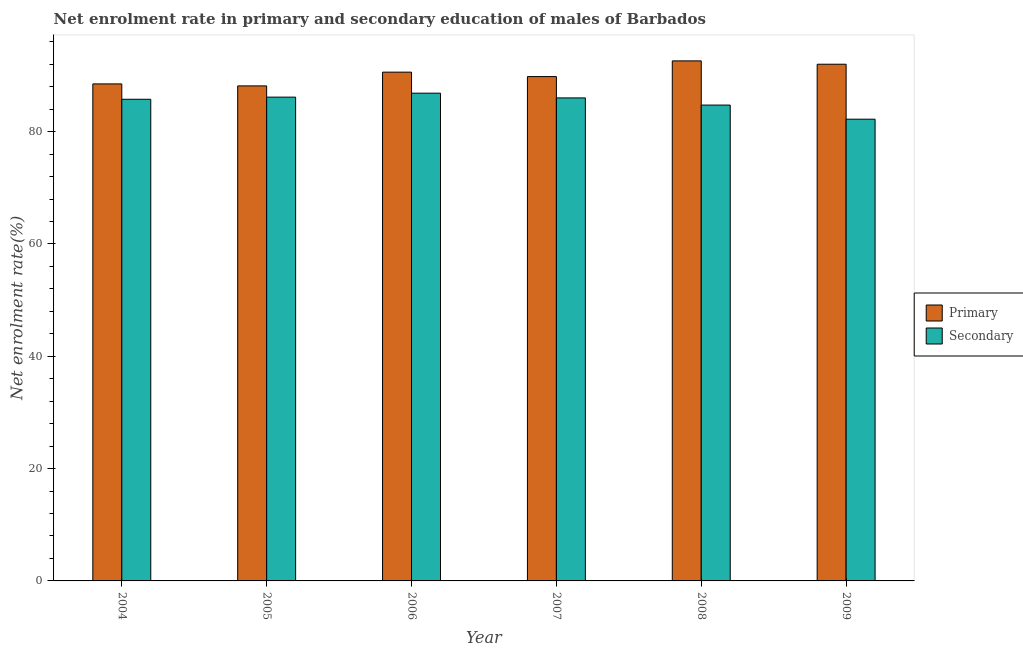How many groups of bars are there?
Give a very brief answer. 6. How many bars are there on the 3rd tick from the left?
Provide a succinct answer. 2. In how many cases, is the number of bars for a given year not equal to the number of legend labels?
Provide a succinct answer. 0. What is the enrollment rate in primary education in 2005?
Offer a terse response. 88.15. Across all years, what is the maximum enrollment rate in primary education?
Your response must be concise. 92.61. Across all years, what is the minimum enrollment rate in secondary education?
Offer a terse response. 82.22. In which year was the enrollment rate in primary education maximum?
Offer a very short reply. 2008. In which year was the enrollment rate in primary education minimum?
Provide a short and direct response. 2005. What is the total enrollment rate in secondary education in the graph?
Your answer should be compact. 511.73. What is the difference between the enrollment rate in secondary education in 2004 and that in 2007?
Keep it short and to the point. -0.24. What is the difference between the enrollment rate in primary education in 2008 and the enrollment rate in secondary education in 2007?
Your response must be concise. 2.8. What is the average enrollment rate in secondary education per year?
Your answer should be compact. 85.29. In how many years, is the enrollment rate in secondary education greater than 8 %?
Your response must be concise. 6. What is the ratio of the enrollment rate in secondary education in 2004 to that in 2005?
Provide a short and direct response. 1. Is the difference between the enrollment rate in primary education in 2006 and 2008 greater than the difference between the enrollment rate in secondary education in 2006 and 2008?
Your response must be concise. No. What is the difference between the highest and the second highest enrollment rate in primary education?
Provide a succinct answer. 0.6. What is the difference between the highest and the lowest enrollment rate in primary education?
Your answer should be very brief. 4.46. In how many years, is the enrollment rate in primary education greater than the average enrollment rate in primary education taken over all years?
Your response must be concise. 3. What does the 2nd bar from the left in 2007 represents?
Your answer should be compact. Secondary. What does the 2nd bar from the right in 2006 represents?
Provide a succinct answer. Primary. How many bars are there?
Provide a succinct answer. 12. Are the values on the major ticks of Y-axis written in scientific E-notation?
Your answer should be very brief. No. Does the graph contain any zero values?
Your response must be concise. No. Where does the legend appear in the graph?
Keep it short and to the point. Center right. How many legend labels are there?
Your response must be concise. 2. How are the legend labels stacked?
Make the answer very short. Vertical. What is the title of the graph?
Ensure brevity in your answer.  Net enrolment rate in primary and secondary education of males of Barbados. What is the label or title of the X-axis?
Provide a short and direct response. Year. What is the label or title of the Y-axis?
Offer a terse response. Net enrolment rate(%). What is the Net enrolment rate(%) of Primary in 2004?
Your answer should be compact. 88.5. What is the Net enrolment rate(%) in Secondary in 2004?
Offer a terse response. 85.77. What is the Net enrolment rate(%) in Primary in 2005?
Your response must be concise. 88.15. What is the Net enrolment rate(%) of Secondary in 2005?
Give a very brief answer. 86.15. What is the Net enrolment rate(%) in Primary in 2006?
Keep it short and to the point. 90.6. What is the Net enrolment rate(%) of Secondary in 2006?
Offer a very short reply. 86.85. What is the Net enrolment rate(%) of Primary in 2007?
Offer a very short reply. 89.81. What is the Net enrolment rate(%) in Secondary in 2007?
Your response must be concise. 86.01. What is the Net enrolment rate(%) of Primary in 2008?
Ensure brevity in your answer.  92.61. What is the Net enrolment rate(%) in Secondary in 2008?
Your answer should be compact. 84.74. What is the Net enrolment rate(%) of Primary in 2009?
Offer a terse response. 92.01. What is the Net enrolment rate(%) in Secondary in 2009?
Provide a short and direct response. 82.22. Across all years, what is the maximum Net enrolment rate(%) of Primary?
Offer a terse response. 92.61. Across all years, what is the maximum Net enrolment rate(%) in Secondary?
Your answer should be very brief. 86.85. Across all years, what is the minimum Net enrolment rate(%) of Primary?
Keep it short and to the point. 88.15. Across all years, what is the minimum Net enrolment rate(%) of Secondary?
Offer a very short reply. 82.22. What is the total Net enrolment rate(%) in Primary in the graph?
Provide a succinct answer. 541.67. What is the total Net enrolment rate(%) in Secondary in the graph?
Ensure brevity in your answer.  511.73. What is the difference between the Net enrolment rate(%) in Primary in 2004 and that in 2005?
Your answer should be compact. 0.36. What is the difference between the Net enrolment rate(%) in Secondary in 2004 and that in 2005?
Provide a succinct answer. -0.38. What is the difference between the Net enrolment rate(%) in Primary in 2004 and that in 2006?
Offer a terse response. -2.1. What is the difference between the Net enrolment rate(%) of Secondary in 2004 and that in 2006?
Keep it short and to the point. -1.08. What is the difference between the Net enrolment rate(%) in Primary in 2004 and that in 2007?
Ensure brevity in your answer.  -1.3. What is the difference between the Net enrolment rate(%) in Secondary in 2004 and that in 2007?
Give a very brief answer. -0.24. What is the difference between the Net enrolment rate(%) of Primary in 2004 and that in 2008?
Offer a terse response. -4.1. What is the difference between the Net enrolment rate(%) in Secondary in 2004 and that in 2008?
Provide a short and direct response. 1.03. What is the difference between the Net enrolment rate(%) of Primary in 2004 and that in 2009?
Ensure brevity in your answer.  -3.5. What is the difference between the Net enrolment rate(%) of Secondary in 2004 and that in 2009?
Offer a very short reply. 3.55. What is the difference between the Net enrolment rate(%) in Primary in 2005 and that in 2006?
Provide a succinct answer. -2.45. What is the difference between the Net enrolment rate(%) in Secondary in 2005 and that in 2006?
Offer a very short reply. -0.7. What is the difference between the Net enrolment rate(%) in Primary in 2005 and that in 2007?
Ensure brevity in your answer.  -1.66. What is the difference between the Net enrolment rate(%) in Secondary in 2005 and that in 2007?
Provide a succinct answer. 0.14. What is the difference between the Net enrolment rate(%) in Primary in 2005 and that in 2008?
Offer a terse response. -4.46. What is the difference between the Net enrolment rate(%) in Secondary in 2005 and that in 2008?
Give a very brief answer. 1.41. What is the difference between the Net enrolment rate(%) of Primary in 2005 and that in 2009?
Make the answer very short. -3.86. What is the difference between the Net enrolment rate(%) in Secondary in 2005 and that in 2009?
Your response must be concise. 3.93. What is the difference between the Net enrolment rate(%) in Primary in 2006 and that in 2007?
Make the answer very short. 0.79. What is the difference between the Net enrolment rate(%) in Secondary in 2006 and that in 2007?
Make the answer very short. 0.84. What is the difference between the Net enrolment rate(%) of Primary in 2006 and that in 2008?
Ensure brevity in your answer.  -2.01. What is the difference between the Net enrolment rate(%) in Secondary in 2006 and that in 2008?
Offer a terse response. 2.12. What is the difference between the Net enrolment rate(%) of Primary in 2006 and that in 2009?
Provide a succinct answer. -1.41. What is the difference between the Net enrolment rate(%) of Secondary in 2006 and that in 2009?
Your response must be concise. 4.63. What is the difference between the Net enrolment rate(%) of Primary in 2007 and that in 2008?
Your response must be concise. -2.8. What is the difference between the Net enrolment rate(%) of Secondary in 2007 and that in 2008?
Offer a very short reply. 1.27. What is the difference between the Net enrolment rate(%) of Primary in 2007 and that in 2009?
Provide a short and direct response. -2.2. What is the difference between the Net enrolment rate(%) of Secondary in 2007 and that in 2009?
Provide a short and direct response. 3.79. What is the difference between the Net enrolment rate(%) of Primary in 2008 and that in 2009?
Make the answer very short. 0.6. What is the difference between the Net enrolment rate(%) of Secondary in 2008 and that in 2009?
Your response must be concise. 2.52. What is the difference between the Net enrolment rate(%) of Primary in 2004 and the Net enrolment rate(%) of Secondary in 2005?
Your response must be concise. 2.36. What is the difference between the Net enrolment rate(%) of Primary in 2004 and the Net enrolment rate(%) of Secondary in 2006?
Offer a very short reply. 1.65. What is the difference between the Net enrolment rate(%) in Primary in 2004 and the Net enrolment rate(%) in Secondary in 2007?
Give a very brief answer. 2.49. What is the difference between the Net enrolment rate(%) in Primary in 2004 and the Net enrolment rate(%) in Secondary in 2008?
Give a very brief answer. 3.77. What is the difference between the Net enrolment rate(%) of Primary in 2004 and the Net enrolment rate(%) of Secondary in 2009?
Make the answer very short. 6.28. What is the difference between the Net enrolment rate(%) in Primary in 2005 and the Net enrolment rate(%) in Secondary in 2006?
Give a very brief answer. 1.3. What is the difference between the Net enrolment rate(%) of Primary in 2005 and the Net enrolment rate(%) of Secondary in 2007?
Your response must be concise. 2.14. What is the difference between the Net enrolment rate(%) in Primary in 2005 and the Net enrolment rate(%) in Secondary in 2008?
Your answer should be very brief. 3.41. What is the difference between the Net enrolment rate(%) in Primary in 2005 and the Net enrolment rate(%) in Secondary in 2009?
Your answer should be very brief. 5.93. What is the difference between the Net enrolment rate(%) of Primary in 2006 and the Net enrolment rate(%) of Secondary in 2007?
Ensure brevity in your answer.  4.59. What is the difference between the Net enrolment rate(%) in Primary in 2006 and the Net enrolment rate(%) in Secondary in 2008?
Your response must be concise. 5.86. What is the difference between the Net enrolment rate(%) in Primary in 2006 and the Net enrolment rate(%) in Secondary in 2009?
Offer a terse response. 8.38. What is the difference between the Net enrolment rate(%) in Primary in 2007 and the Net enrolment rate(%) in Secondary in 2008?
Give a very brief answer. 5.07. What is the difference between the Net enrolment rate(%) in Primary in 2007 and the Net enrolment rate(%) in Secondary in 2009?
Provide a short and direct response. 7.59. What is the difference between the Net enrolment rate(%) in Primary in 2008 and the Net enrolment rate(%) in Secondary in 2009?
Your response must be concise. 10.39. What is the average Net enrolment rate(%) of Primary per year?
Make the answer very short. 90.28. What is the average Net enrolment rate(%) of Secondary per year?
Provide a short and direct response. 85.29. In the year 2004, what is the difference between the Net enrolment rate(%) of Primary and Net enrolment rate(%) of Secondary?
Offer a very short reply. 2.74. In the year 2005, what is the difference between the Net enrolment rate(%) in Primary and Net enrolment rate(%) in Secondary?
Your answer should be compact. 2. In the year 2006, what is the difference between the Net enrolment rate(%) of Primary and Net enrolment rate(%) of Secondary?
Keep it short and to the point. 3.75. In the year 2007, what is the difference between the Net enrolment rate(%) in Primary and Net enrolment rate(%) in Secondary?
Your response must be concise. 3.8. In the year 2008, what is the difference between the Net enrolment rate(%) in Primary and Net enrolment rate(%) in Secondary?
Keep it short and to the point. 7.87. In the year 2009, what is the difference between the Net enrolment rate(%) of Primary and Net enrolment rate(%) of Secondary?
Keep it short and to the point. 9.79. What is the ratio of the Net enrolment rate(%) of Primary in 2004 to that in 2005?
Your answer should be compact. 1. What is the ratio of the Net enrolment rate(%) of Primary in 2004 to that in 2006?
Make the answer very short. 0.98. What is the ratio of the Net enrolment rate(%) of Secondary in 2004 to that in 2006?
Give a very brief answer. 0.99. What is the ratio of the Net enrolment rate(%) in Primary in 2004 to that in 2007?
Your response must be concise. 0.99. What is the ratio of the Net enrolment rate(%) in Primary in 2004 to that in 2008?
Provide a succinct answer. 0.96. What is the ratio of the Net enrolment rate(%) of Secondary in 2004 to that in 2008?
Your answer should be compact. 1.01. What is the ratio of the Net enrolment rate(%) of Primary in 2004 to that in 2009?
Provide a short and direct response. 0.96. What is the ratio of the Net enrolment rate(%) of Secondary in 2004 to that in 2009?
Your answer should be compact. 1.04. What is the ratio of the Net enrolment rate(%) in Primary in 2005 to that in 2006?
Give a very brief answer. 0.97. What is the ratio of the Net enrolment rate(%) of Secondary in 2005 to that in 2006?
Keep it short and to the point. 0.99. What is the ratio of the Net enrolment rate(%) of Primary in 2005 to that in 2007?
Offer a terse response. 0.98. What is the ratio of the Net enrolment rate(%) in Primary in 2005 to that in 2008?
Your response must be concise. 0.95. What is the ratio of the Net enrolment rate(%) of Secondary in 2005 to that in 2008?
Your response must be concise. 1.02. What is the ratio of the Net enrolment rate(%) in Primary in 2005 to that in 2009?
Provide a succinct answer. 0.96. What is the ratio of the Net enrolment rate(%) of Secondary in 2005 to that in 2009?
Make the answer very short. 1.05. What is the ratio of the Net enrolment rate(%) of Primary in 2006 to that in 2007?
Make the answer very short. 1.01. What is the ratio of the Net enrolment rate(%) in Secondary in 2006 to that in 2007?
Make the answer very short. 1.01. What is the ratio of the Net enrolment rate(%) of Primary in 2006 to that in 2008?
Your response must be concise. 0.98. What is the ratio of the Net enrolment rate(%) in Primary in 2006 to that in 2009?
Provide a succinct answer. 0.98. What is the ratio of the Net enrolment rate(%) of Secondary in 2006 to that in 2009?
Offer a very short reply. 1.06. What is the ratio of the Net enrolment rate(%) in Primary in 2007 to that in 2008?
Make the answer very short. 0.97. What is the ratio of the Net enrolment rate(%) in Primary in 2007 to that in 2009?
Keep it short and to the point. 0.98. What is the ratio of the Net enrolment rate(%) of Secondary in 2007 to that in 2009?
Provide a succinct answer. 1.05. What is the ratio of the Net enrolment rate(%) of Primary in 2008 to that in 2009?
Give a very brief answer. 1.01. What is the ratio of the Net enrolment rate(%) of Secondary in 2008 to that in 2009?
Your answer should be very brief. 1.03. What is the difference between the highest and the second highest Net enrolment rate(%) of Primary?
Ensure brevity in your answer.  0.6. What is the difference between the highest and the second highest Net enrolment rate(%) in Secondary?
Provide a succinct answer. 0.7. What is the difference between the highest and the lowest Net enrolment rate(%) in Primary?
Offer a terse response. 4.46. What is the difference between the highest and the lowest Net enrolment rate(%) in Secondary?
Provide a short and direct response. 4.63. 